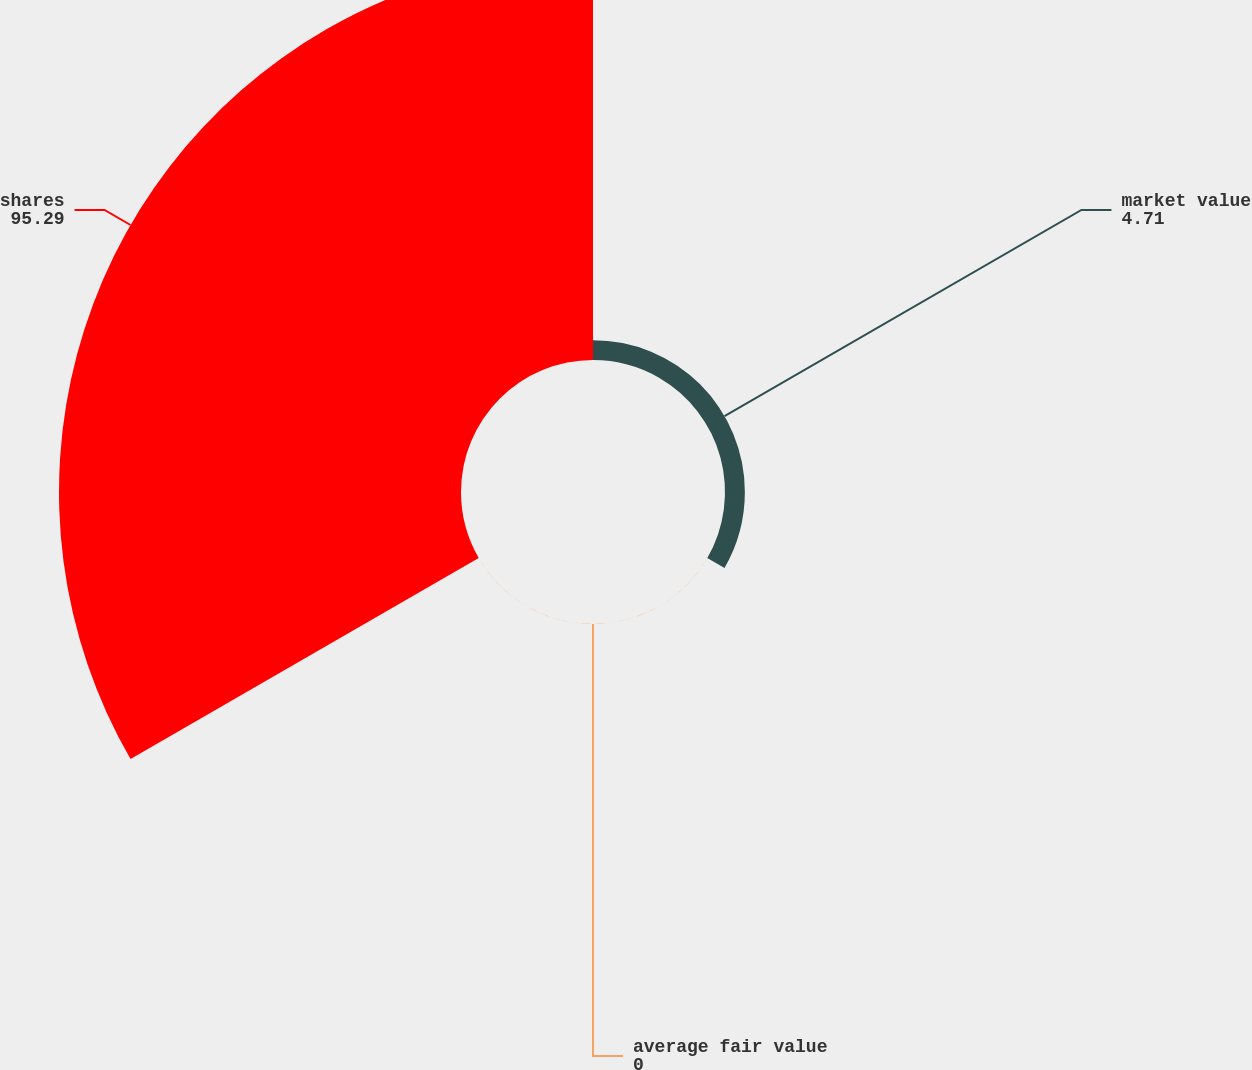Convert chart to OTSL. <chart><loc_0><loc_0><loc_500><loc_500><pie_chart><fcel>market value<fcel>average fair value<fcel>shares<nl><fcel>4.71%<fcel>0.0%<fcel>95.29%<nl></chart> 